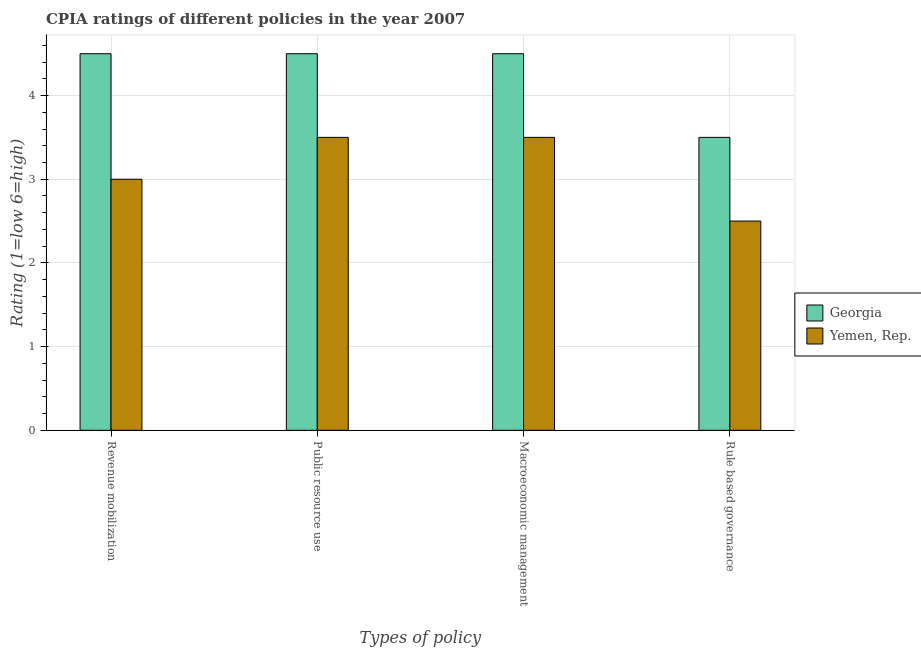How many different coloured bars are there?
Provide a succinct answer. 2. How many groups of bars are there?
Ensure brevity in your answer.  4. Are the number of bars per tick equal to the number of legend labels?
Ensure brevity in your answer.  Yes. What is the label of the 3rd group of bars from the left?
Your response must be concise. Macroeconomic management. In which country was the cpia rating of macroeconomic management maximum?
Make the answer very short. Georgia. In which country was the cpia rating of rule based governance minimum?
Give a very brief answer. Yemen, Rep. What is the difference between the cpia rating of macroeconomic management in Georgia and that in Yemen, Rep.?
Give a very brief answer. 1. What is the difference between the cpia rating of public resource use and cpia rating of revenue mobilization in Yemen, Rep.?
Your answer should be very brief. 0.5. In how many countries, is the cpia rating of public resource use greater than 1.8 ?
Offer a very short reply. 2. What is the ratio of the cpia rating of public resource use in Yemen, Rep. to that in Georgia?
Provide a succinct answer. 0.78. Is the cpia rating of macroeconomic management in Yemen, Rep. less than that in Georgia?
Your answer should be compact. Yes. What is the difference between the highest and the second highest cpia rating of revenue mobilization?
Offer a very short reply. 1.5. In how many countries, is the cpia rating of macroeconomic management greater than the average cpia rating of macroeconomic management taken over all countries?
Provide a succinct answer. 1. Is the sum of the cpia rating of public resource use in Georgia and Yemen, Rep. greater than the maximum cpia rating of revenue mobilization across all countries?
Offer a very short reply. Yes. Is it the case that in every country, the sum of the cpia rating of revenue mobilization and cpia rating of macroeconomic management is greater than the sum of cpia rating of public resource use and cpia rating of rule based governance?
Keep it short and to the point. No. What does the 1st bar from the left in Rule based governance represents?
Give a very brief answer. Georgia. What does the 2nd bar from the right in Macroeconomic management represents?
Keep it short and to the point. Georgia. Is it the case that in every country, the sum of the cpia rating of revenue mobilization and cpia rating of public resource use is greater than the cpia rating of macroeconomic management?
Provide a succinct answer. Yes. How many bars are there?
Provide a short and direct response. 8. What is the difference between two consecutive major ticks on the Y-axis?
Provide a succinct answer. 1. Are the values on the major ticks of Y-axis written in scientific E-notation?
Ensure brevity in your answer.  No. Does the graph contain any zero values?
Your answer should be very brief. No. Does the graph contain grids?
Keep it short and to the point. Yes. How many legend labels are there?
Provide a short and direct response. 2. How are the legend labels stacked?
Your answer should be very brief. Vertical. What is the title of the graph?
Your response must be concise. CPIA ratings of different policies in the year 2007. Does "Albania" appear as one of the legend labels in the graph?
Your answer should be very brief. No. What is the label or title of the X-axis?
Offer a terse response. Types of policy. What is the Rating (1=low 6=high) of Yemen, Rep. in Public resource use?
Your answer should be compact. 3.5. What is the Rating (1=low 6=high) in Yemen, Rep. in Macroeconomic management?
Your answer should be compact. 3.5. What is the Rating (1=low 6=high) in Georgia in Rule based governance?
Ensure brevity in your answer.  3.5. Across all Types of policy, what is the maximum Rating (1=low 6=high) in Yemen, Rep.?
Your answer should be very brief. 3.5. Across all Types of policy, what is the minimum Rating (1=low 6=high) in Yemen, Rep.?
Make the answer very short. 2.5. What is the total Rating (1=low 6=high) of Yemen, Rep. in the graph?
Offer a terse response. 12.5. What is the difference between the Rating (1=low 6=high) in Georgia in Revenue mobilization and that in Public resource use?
Provide a succinct answer. 0. What is the difference between the Rating (1=low 6=high) in Yemen, Rep. in Revenue mobilization and that in Public resource use?
Make the answer very short. -0.5. What is the difference between the Rating (1=low 6=high) in Yemen, Rep. in Revenue mobilization and that in Macroeconomic management?
Offer a very short reply. -0.5. What is the difference between the Rating (1=low 6=high) in Georgia in Revenue mobilization and that in Rule based governance?
Your answer should be compact. 1. What is the difference between the Rating (1=low 6=high) in Georgia in Public resource use and that in Macroeconomic management?
Give a very brief answer. 0. What is the difference between the Rating (1=low 6=high) in Yemen, Rep. in Public resource use and that in Rule based governance?
Give a very brief answer. 1. What is the difference between the Rating (1=low 6=high) of Georgia in Revenue mobilization and the Rating (1=low 6=high) of Yemen, Rep. in Public resource use?
Your response must be concise. 1. What is the difference between the Rating (1=low 6=high) in Georgia in Revenue mobilization and the Rating (1=low 6=high) in Yemen, Rep. in Rule based governance?
Ensure brevity in your answer.  2. What is the average Rating (1=low 6=high) in Georgia per Types of policy?
Provide a succinct answer. 4.25. What is the average Rating (1=low 6=high) in Yemen, Rep. per Types of policy?
Your answer should be compact. 3.12. What is the difference between the Rating (1=low 6=high) in Georgia and Rating (1=low 6=high) in Yemen, Rep. in Revenue mobilization?
Make the answer very short. 1.5. What is the difference between the Rating (1=low 6=high) in Georgia and Rating (1=low 6=high) in Yemen, Rep. in Public resource use?
Ensure brevity in your answer.  1. What is the difference between the Rating (1=low 6=high) of Georgia and Rating (1=low 6=high) of Yemen, Rep. in Rule based governance?
Ensure brevity in your answer.  1. What is the ratio of the Rating (1=low 6=high) of Georgia in Revenue mobilization to that in Macroeconomic management?
Offer a terse response. 1. What is the ratio of the Rating (1=low 6=high) of Georgia in Revenue mobilization to that in Rule based governance?
Keep it short and to the point. 1.29. What is the ratio of the Rating (1=low 6=high) in Yemen, Rep. in Revenue mobilization to that in Rule based governance?
Your answer should be very brief. 1.2. What is the ratio of the Rating (1=low 6=high) in Georgia in Macroeconomic management to that in Rule based governance?
Your answer should be compact. 1.29. What is the difference between the highest and the second highest Rating (1=low 6=high) in Yemen, Rep.?
Provide a short and direct response. 0. 